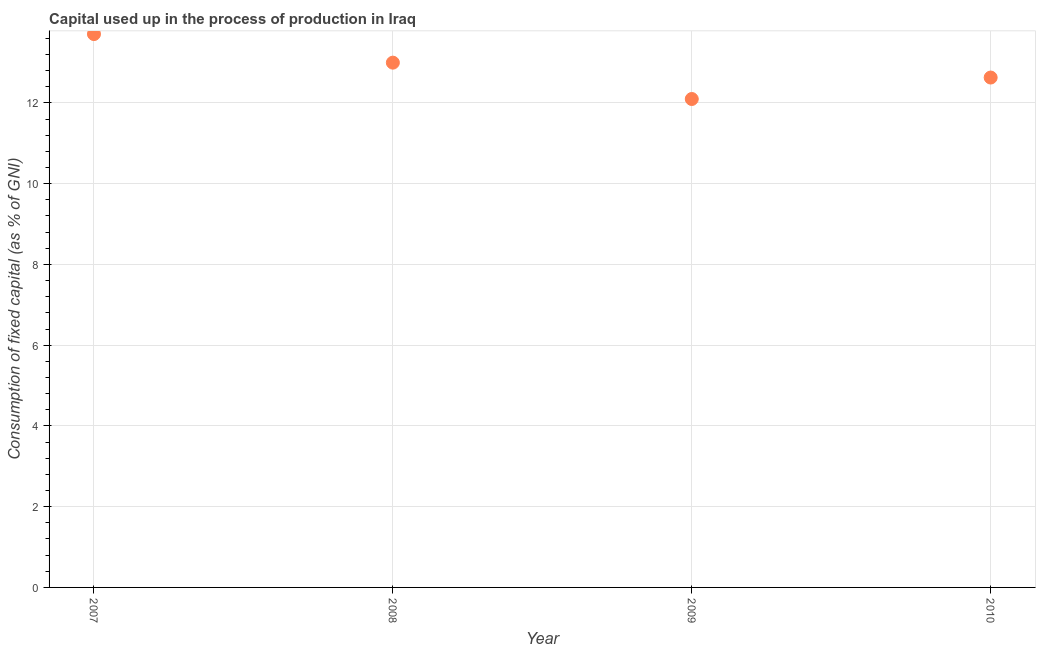What is the consumption of fixed capital in 2009?
Make the answer very short. 12.1. Across all years, what is the maximum consumption of fixed capital?
Your answer should be very brief. 13.71. Across all years, what is the minimum consumption of fixed capital?
Keep it short and to the point. 12.1. In which year was the consumption of fixed capital maximum?
Make the answer very short. 2007. In which year was the consumption of fixed capital minimum?
Your response must be concise. 2009. What is the sum of the consumption of fixed capital?
Provide a succinct answer. 51.43. What is the difference between the consumption of fixed capital in 2008 and 2009?
Keep it short and to the point. 0.9. What is the average consumption of fixed capital per year?
Your answer should be very brief. 12.86. What is the median consumption of fixed capital?
Your response must be concise. 12.81. What is the ratio of the consumption of fixed capital in 2008 to that in 2009?
Your response must be concise. 1.07. Is the difference between the consumption of fixed capital in 2007 and 2008 greater than the difference between any two years?
Make the answer very short. No. What is the difference between the highest and the second highest consumption of fixed capital?
Your answer should be very brief. 0.71. Is the sum of the consumption of fixed capital in 2007 and 2009 greater than the maximum consumption of fixed capital across all years?
Offer a terse response. Yes. What is the difference between the highest and the lowest consumption of fixed capital?
Your answer should be very brief. 1.61. Does the consumption of fixed capital monotonically increase over the years?
Offer a very short reply. No. Are the values on the major ticks of Y-axis written in scientific E-notation?
Provide a succinct answer. No. Does the graph contain grids?
Your answer should be very brief. Yes. What is the title of the graph?
Offer a terse response. Capital used up in the process of production in Iraq. What is the label or title of the Y-axis?
Make the answer very short. Consumption of fixed capital (as % of GNI). What is the Consumption of fixed capital (as % of GNI) in 2007?
Offer a very short reply. 13.71. What is the Consumption of fixed capital (as % of GNI) in 2008?
Ensure brevity in your answer.  13. What is the Consumption of fixed capital (as % of GNI) in 2009?
Your answer should be compact. 12.1. What is the Consumption of fixed capital (as % of GNI) in 2010?
Make the answer very short. 12.63. What is the difference between the Consumption of fixed capital (as % of GNI) in 2007 and 2008?
Give a very brief answer. 0.71. What is the difference between the Consumption of fixed capital (as % of GNI) in 2007 and 2009?
Give a very brief answer. 1.61. What is the difference between the Consumption of fixed capital (as % of GNI) in 2007 and 2010?
Make the answer very short. 1.08. What is the difference between the Consumption of fixed capital (as % of GNI) in 2008 and 2009?
Keep it short and to the point. 0.9. What is the difference between the Consumption of fixed capital (as % of GNI) in 2008 and 2010?
Your answer should be compact. 0.37. What is the difference between the Consumption of fixed capital (as % of GNI) in 2009 and 2010?
Provide a succinct answer. -0.53. What is the ratio of the Consumption of fixed capital (as % of GNI) in 2007 to that in 2008?
Give a very brief answer. 1.05. What is the ratio of the Consumption of fixed capital (as % of GNI) in 2007 to that in 2009?
Keep it short and to the point. 1.13. What is the ratio of the Consumption of fixed capital (as % of GNI) in 2007 to that in 2010?
Provide a succinct answer. 1.08. What is the ratio of the Consumption of fixed capital (as % of GNI) in 2008 to that in 2009?
Ensure brevity in your answer.  1.07. What is the ratio of the Consumption of fixed capital (as % of GNI) in 2008 to that in 2010?
Provide a succinct answer. 1.03. What is the ratio of the Consumption of fixed capital (as % of GNI) in 2009 to that in 2010?
Your answer should be very brief. 0.96. 